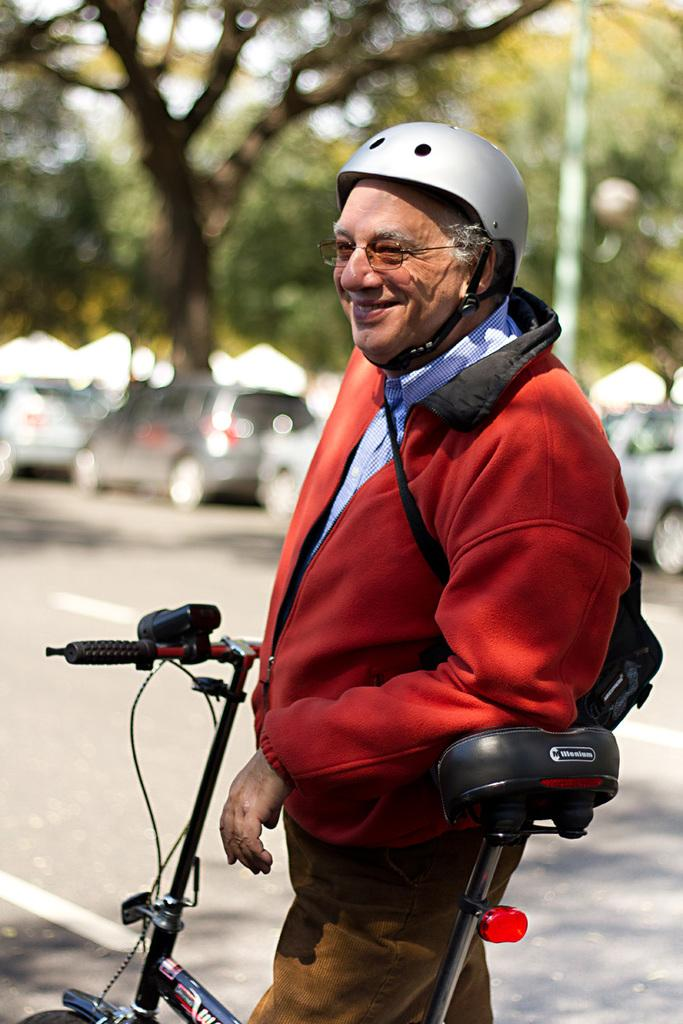Who is present in the image? There is a man in the image. What is the man doing in the image? The man is standing near a bicycle. What can be seen in the background of the image? There are cars and trees in the background of the image. What type of shoes is the actor wearing in the image? There is no actor present in the image, and therefore no shoes to describe. 